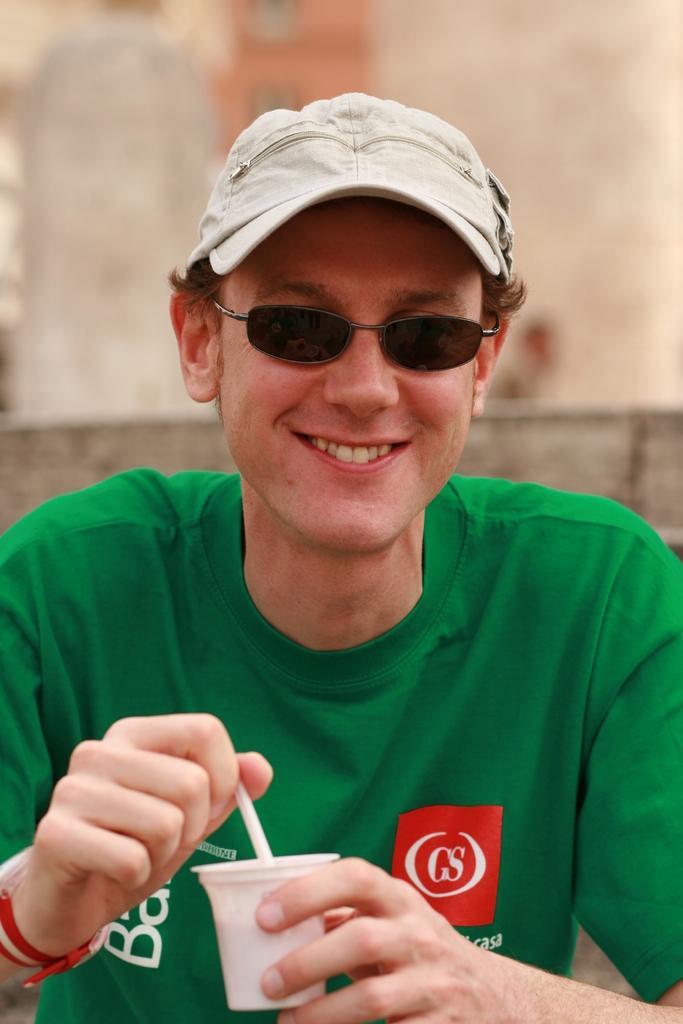Could you give a brief overview of what you see in this image? In this image, we can see a person wearing goggles and cap. He is holding a cup and object. Here we can see man is smiling. Background we can see the blur view. On his goggles, we can see few reflections. 